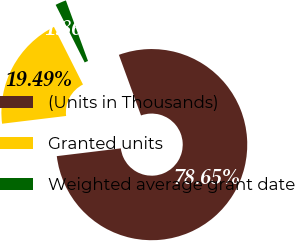Convert chart. <chart><loc_0><loc_0><loc_500><loc_500><pie_chart><fcel>(Units in Thousands)<fcel>Granted units<fcel>Weighted average grant date<nl><fcel>78.66%<fcel>19.49%<fcel>1.86%<nl></chart> 